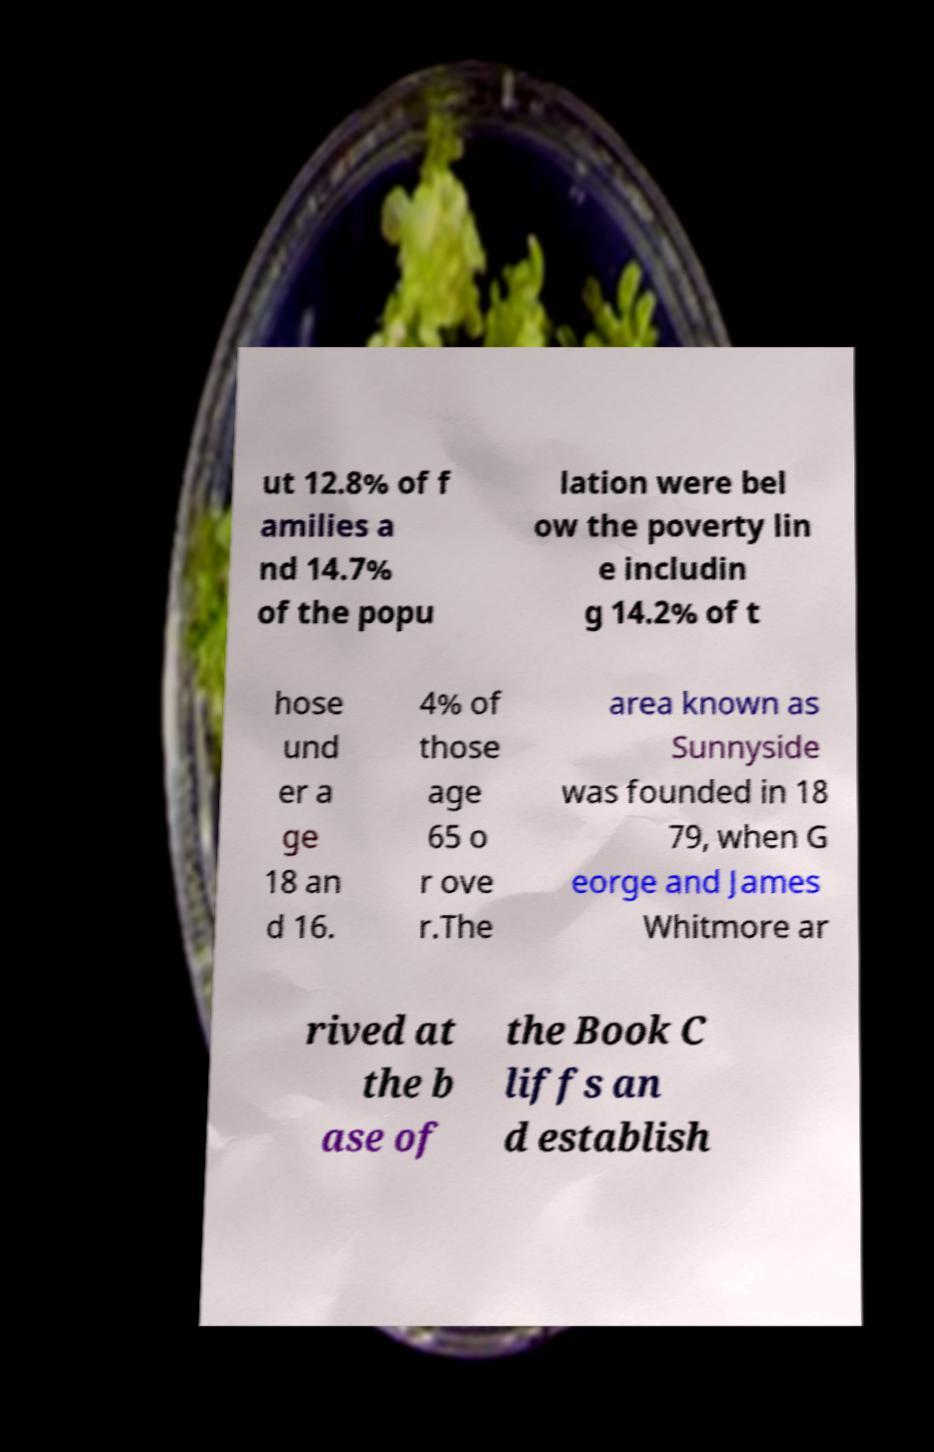Please identify and transcribe the text found in this image. ut 12.8% of f amilies a nd 14.7% of the popu lation were bel ow the poverty lin e includin g 14.2% of t hose und er a ge 18 an d 16. 4% of those age 65 o r ove r.The area known as Sunnyside was founded in 18 79, when G eorge and James Whitmore ar rived at the b ase of the Book C liffs an d establish 